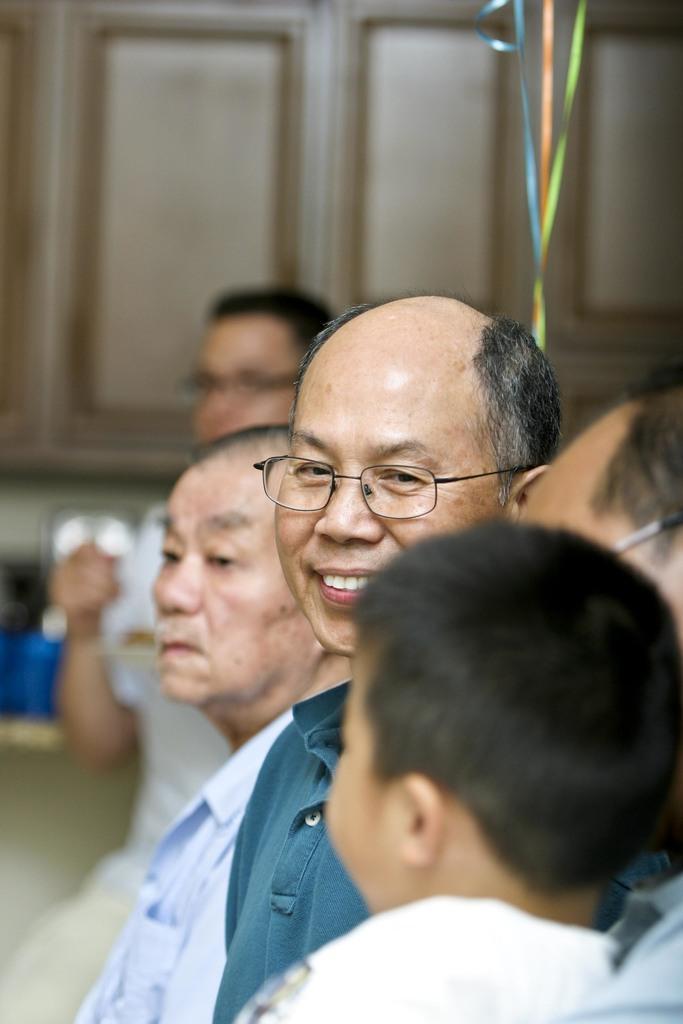Please provide a concise description of this image. In the foreground of the picture we can see group of people. In the middle there are ribbons. The background is blurred. In the background we can see a person and wooden objects. 